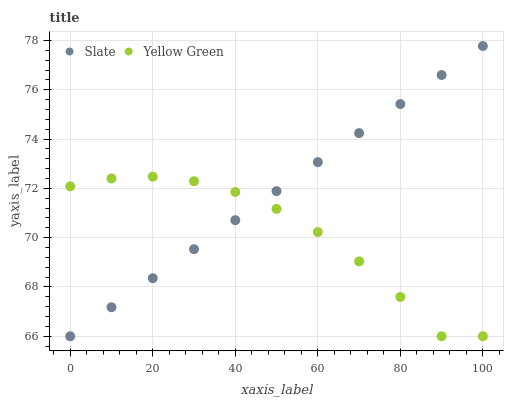Does Yellow Green have the minimum area under the curve?
Answer yes or no. Yes. Does Slate have the maximum area under the curve?
Answer yes or no. Yes. Does Yellow Green have the maximum area under the curve?
Answer yes or no. No. Is Slate the smoothest?
Answer yes or no. Yes. Is Yellow Green the roughest?
Answer yes or no. Yes. Is Yellow Green the smoothest?
Answer yes or no. No. Does Slate have the lowest value?
Answer yes or no. Yes. Does Slate have the highest value?
Answer yes or no. Yes. Does Yellow Green have the highest value?
Answer yes or no. No. Does Slate intersect Yellow Green?
Answer yes or no. Yes. Is Slate less than Yellow Green?
Answer yes or no. No. Is Slate greater than Yellow Green?
Answer yes or no. No. 